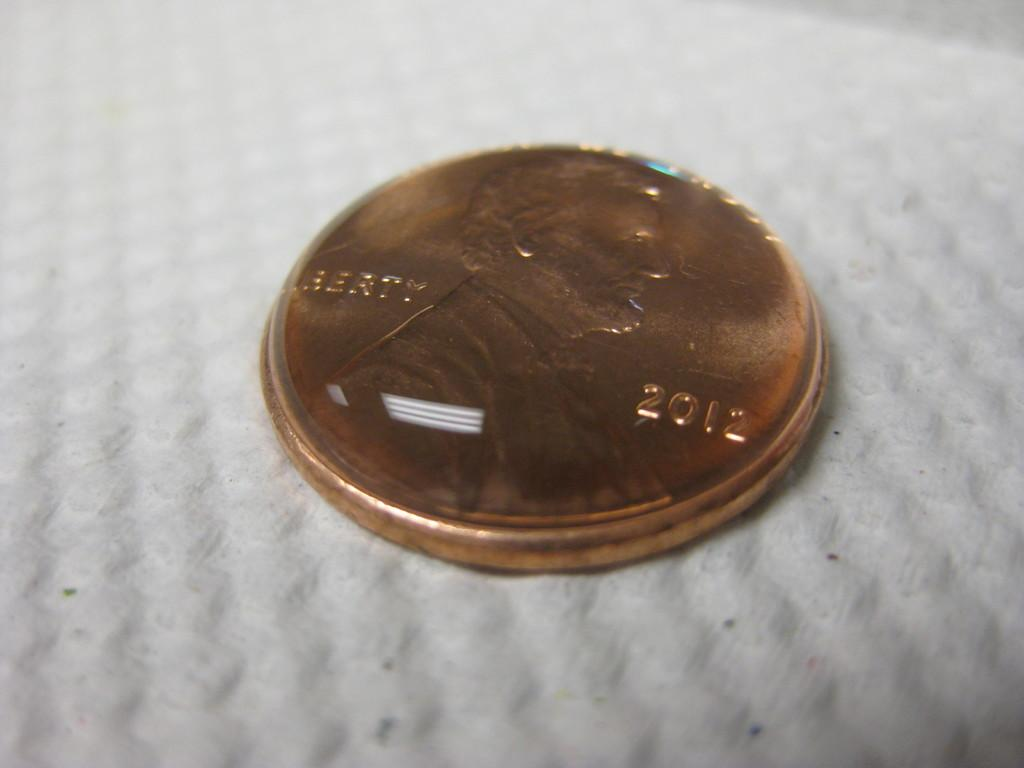<image>
Render a clear and concise summary of the photo. A penny from 2012 has a water droplet on it. 